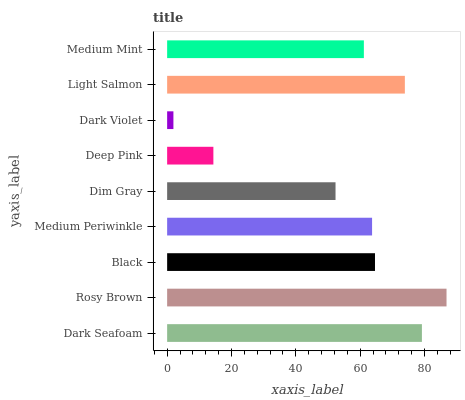Is Dark Violet the minimum?
Answer yes or no. Yes. Is Rosy Brown the maximum?
Answer yes or no. Yes. Is Black the minimum?
Answer yes or no. No. Is Black the maximum?
Answer yes or no. No. Is Rosy Brown greater than Black?
Answer yes or no. Yes. Is Black less than Rosy Brown?
Answer yes or no. Yes. Is Black greater than Rosy Brown?
Answer yes or no. No. Is Rosy Brown less than Black?
Answer yes or no. No. Is Medium Periwinkle the high median?
Answer yes or no. Yes. Is Medium Periwinkle the low median?
Answer yes or no. Yes. Is Dim Gray the high median?
Answer yes or no. No. Is Deep Pink the low median?
Answer yes or no. No. 